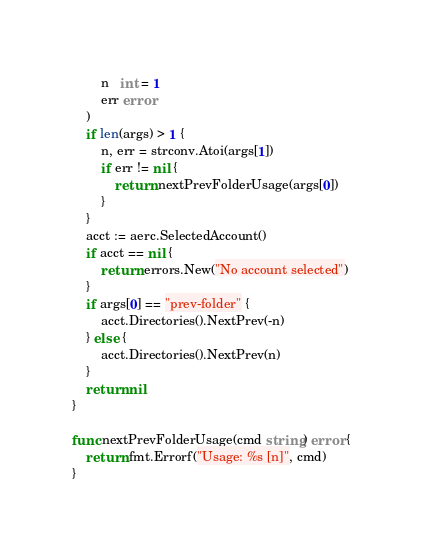Convert code to text. <code><loc_0><loc_0><loc_500><loc_500><_Go_>		n   int = 1
		err error
	)
	if len(args) > 1 {
		n, err = strconv.Atoi(args[1])
		if err != nil {
			return nextPrevFolderUsage(args[0])
		}
	}
	acct := aerc.SelectedAccount()
	if acct == nil {
		return errors.New("No account selected")
	}
	if args[0] == "prev-folder" {
		acct.Directories().NextPrev(-n)
	} else {
		acct.Directories().NextPrev(n)
	}
	return nil
}

func nextPrevFolderUsage(cmd string) error {
	return fmt.Errorf("Usage: %s [n]", cmd)
}
</code> 